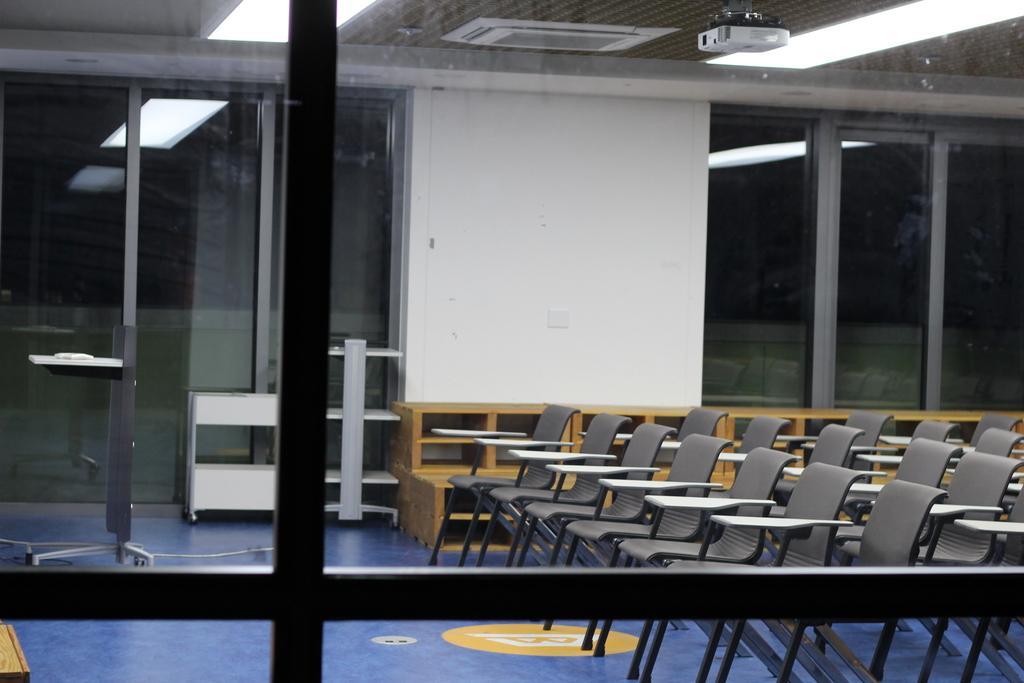In one or two sentences, can you explain what this image depicts? In front of the image there is a glass door. Behind the glass door inside the room there are chairs, podium, tables and a glass door. At the top of the image on the roof there are lights, projector and an AC. 